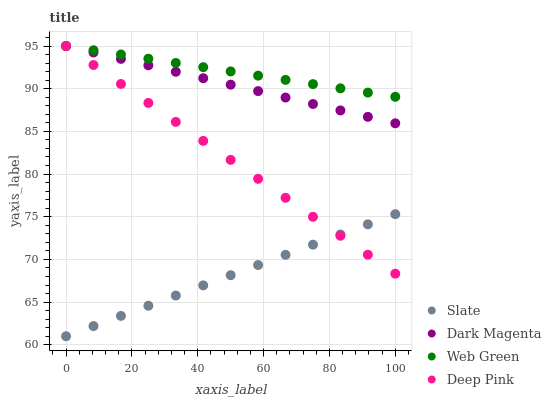Does Slate have the minimum area under the curve?
Answer yes or no. Yes. Does Web Green have the maximum area under the curve?
Answer yes or no. Yes. Does Deep Pink have the minimum area under the curve?
Answer yes or no. No. Does Deep Pink have the maximum area under the curve?
Answer yes or no. No. Is Web Green the smoothest?
Answer yes or no. Yes. Is Dark Magenta the roughest?
Answer yes or no. Yes. Is Deep Pink the smoothest?
Answer yes or no. No. Is Deep Pink the roughest?
Answer yes or no. No. Does Slate have the lowest value?
Answer yes or no. Yes. Does Deep Pink have the lowest value?
Answer yes or no. No. Does Web Green have the highest value?
Answer yes or no. Yes. Is Slate less than Web Green?
Answer yes or no. Yes. Is Dark Magenta greater than Slate?
Answer yes or no. Yes. Does Deep Pink intersect Slate?
Answer yes or no. Yes. Is Deep Pink less than Slate?
Answer yes or no. No. Is Deep Pink greater than Slate?
Answer yes or no. No. Does Slate intersect Web Green?
Answer yes or no. No. 